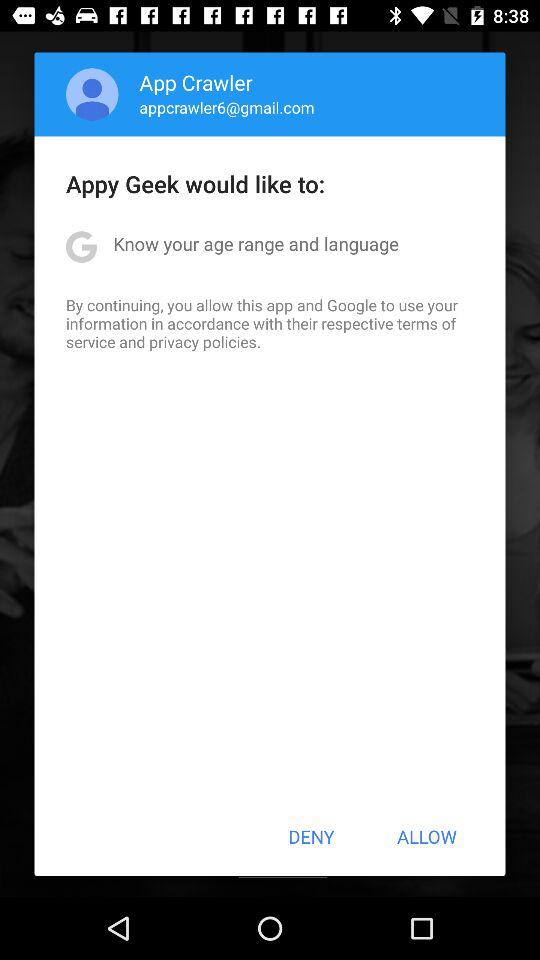Who is curious about the age range and language? The age range and language are of interest to "Appy Geek". 